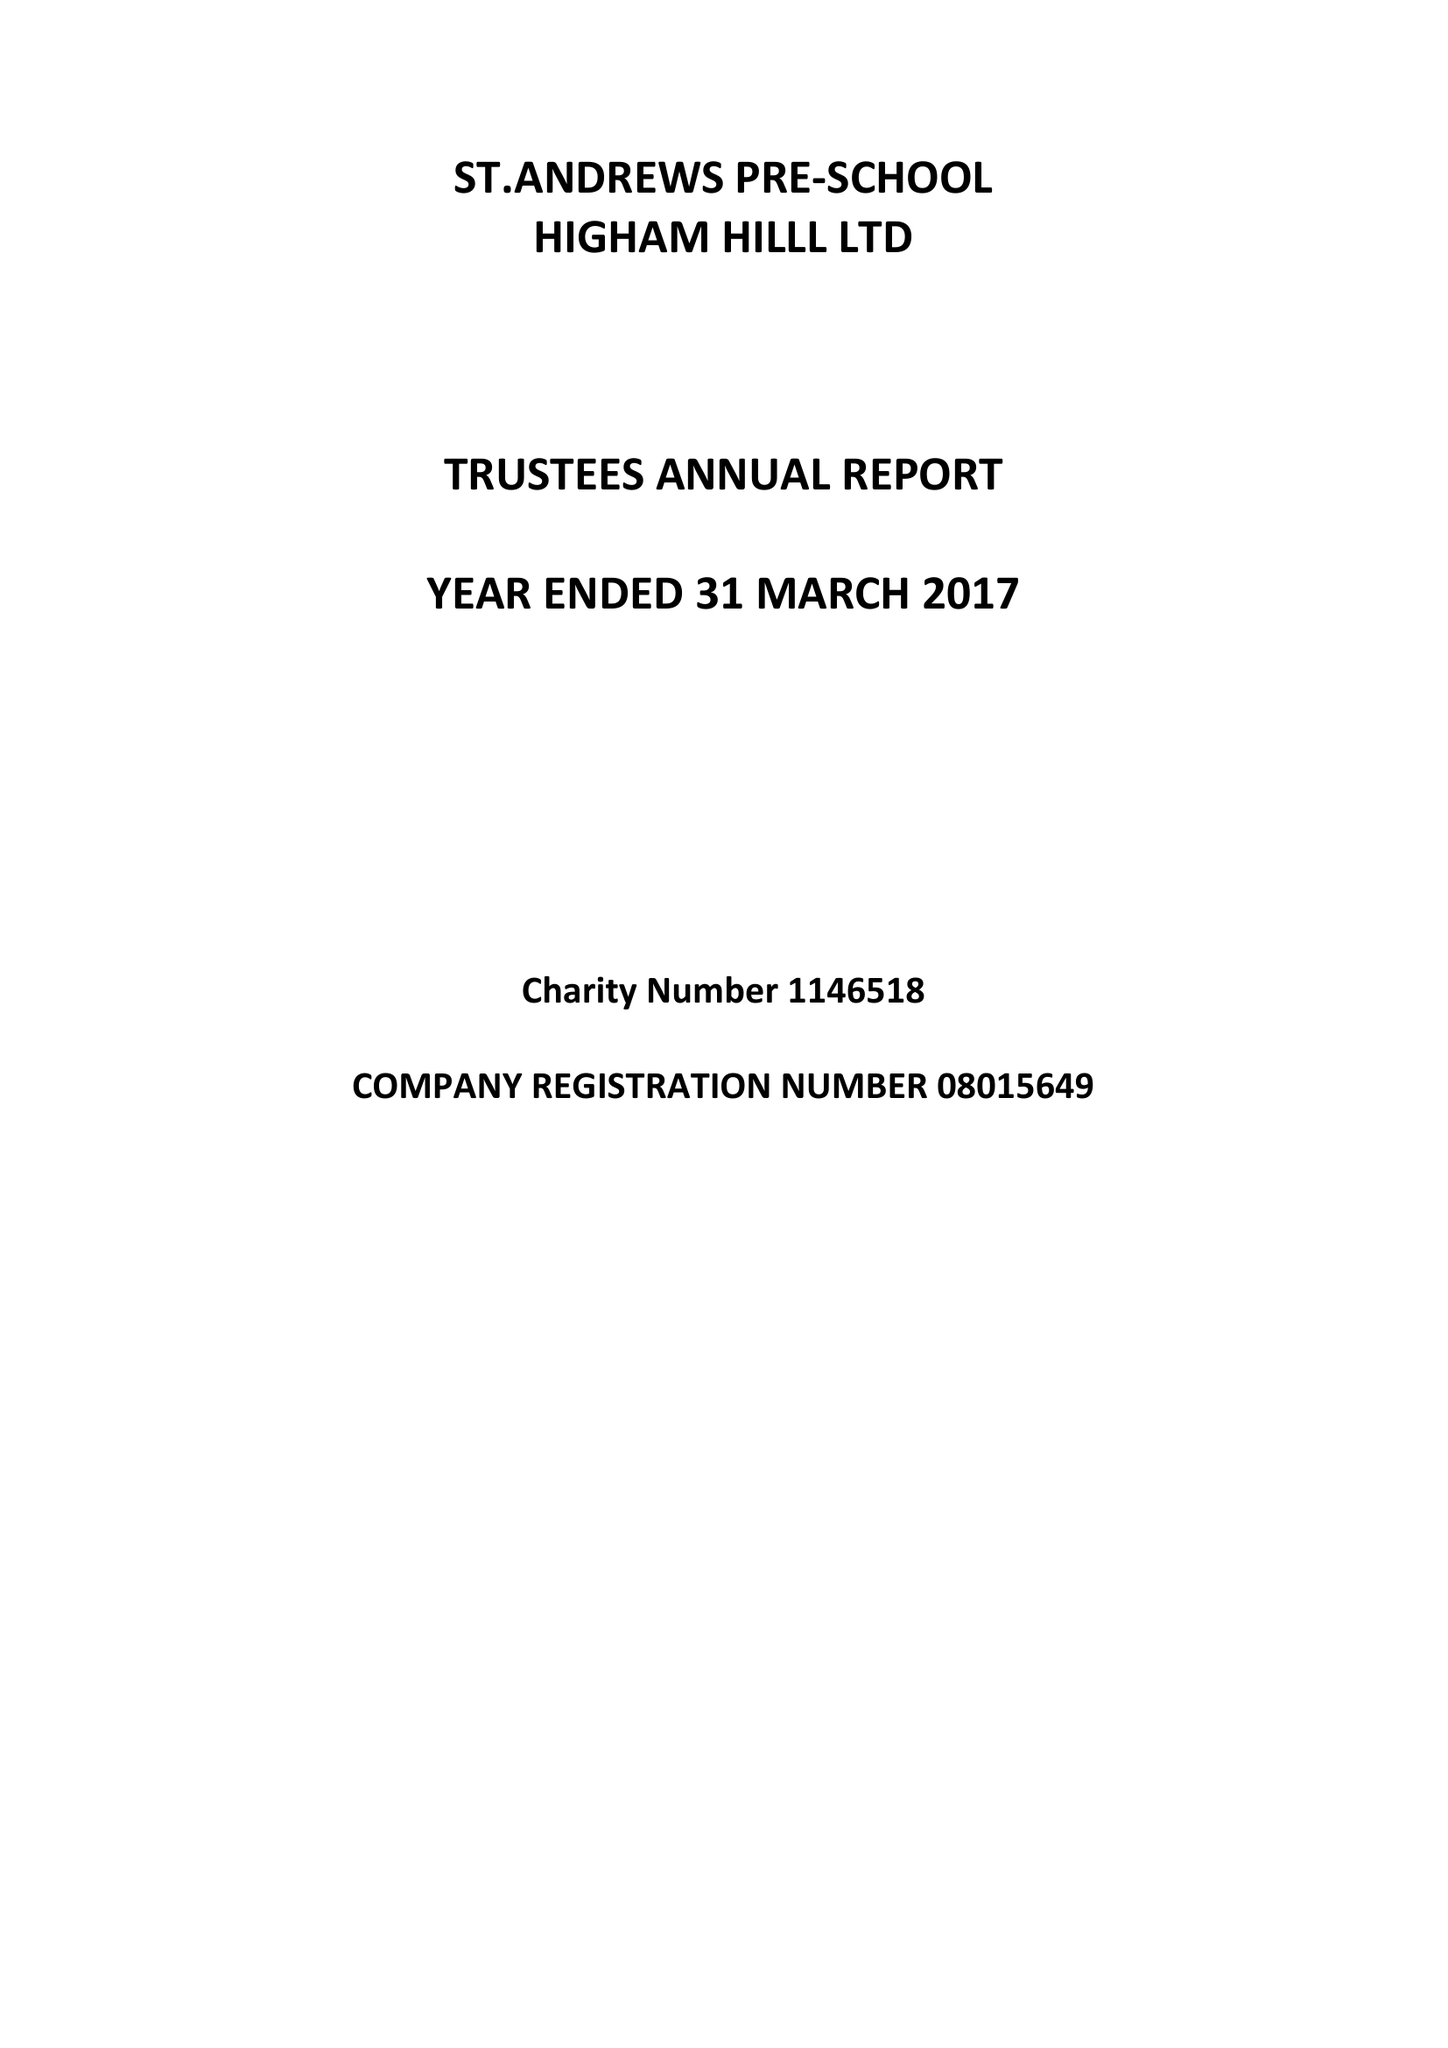What is the value for the address__post_town?
Answer the question using a single word or phrase. LONDON 